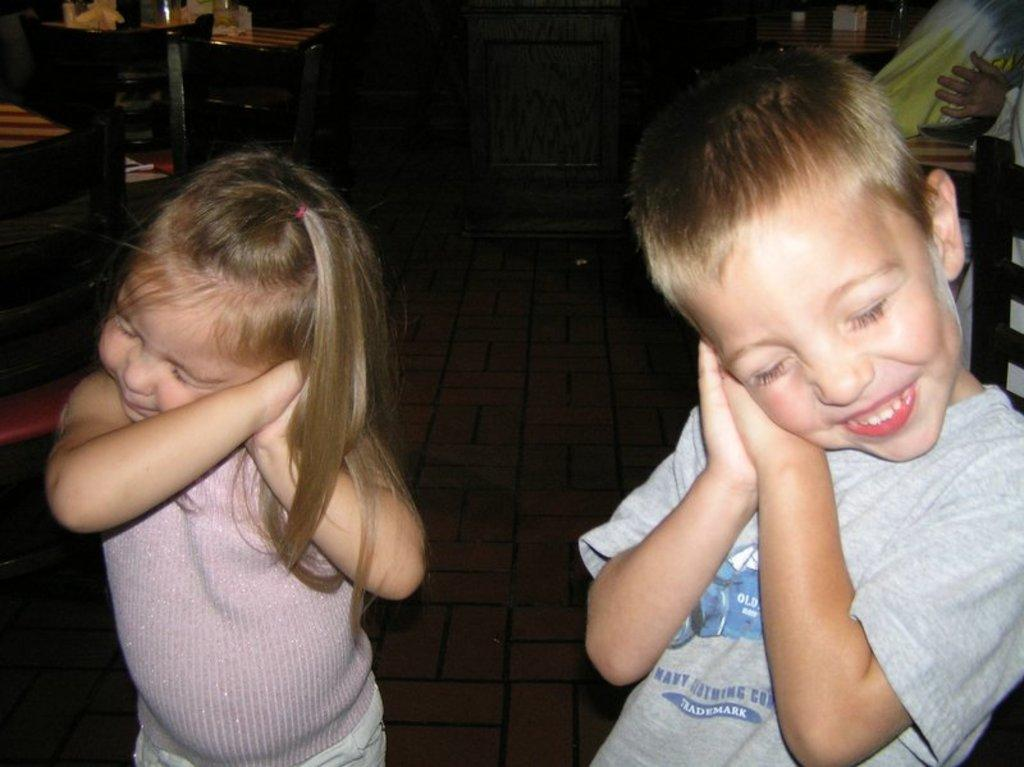How many kids are present in the image? There are two kids in the image. What are the kids doing in the image? The kids are standing in the image. What type of furniture can be seen in the image? There are tables and chairs in the image. What type of card is the kid holding in the image? There is no card present in the image; the kids are simply standing. How many cushions are visible on the chairs in the image? There is no mention of cushions on the chairs in the image; only chairs are mentioned. 